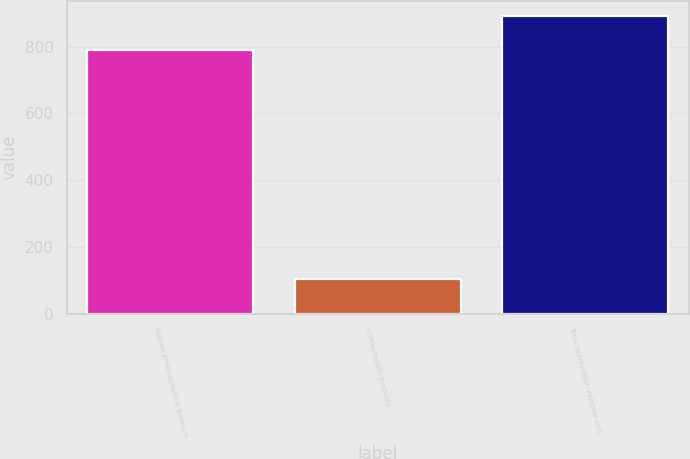Convert chart to OTSL. <chart><loc_0><loc_0><loc_500><loc_500><bar_chart><fcel>Human pharmaceutical products<fcel>Animal health products<fcel>Total depreciation expense and<nl><fcel>789.8<fcel>102.7<fcel>892.5<nl></chart> 